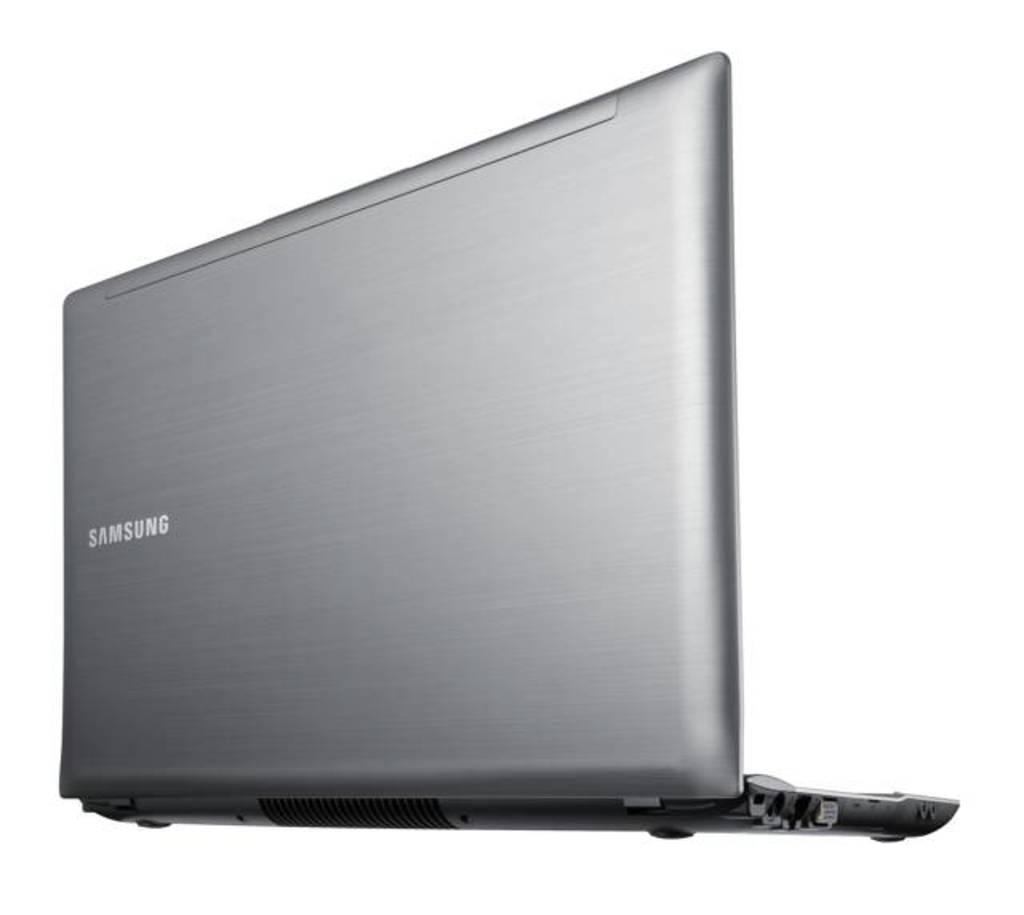<image>
Provide a brief description of the given image. A samsung laptop from the rear  with the lid opened. 